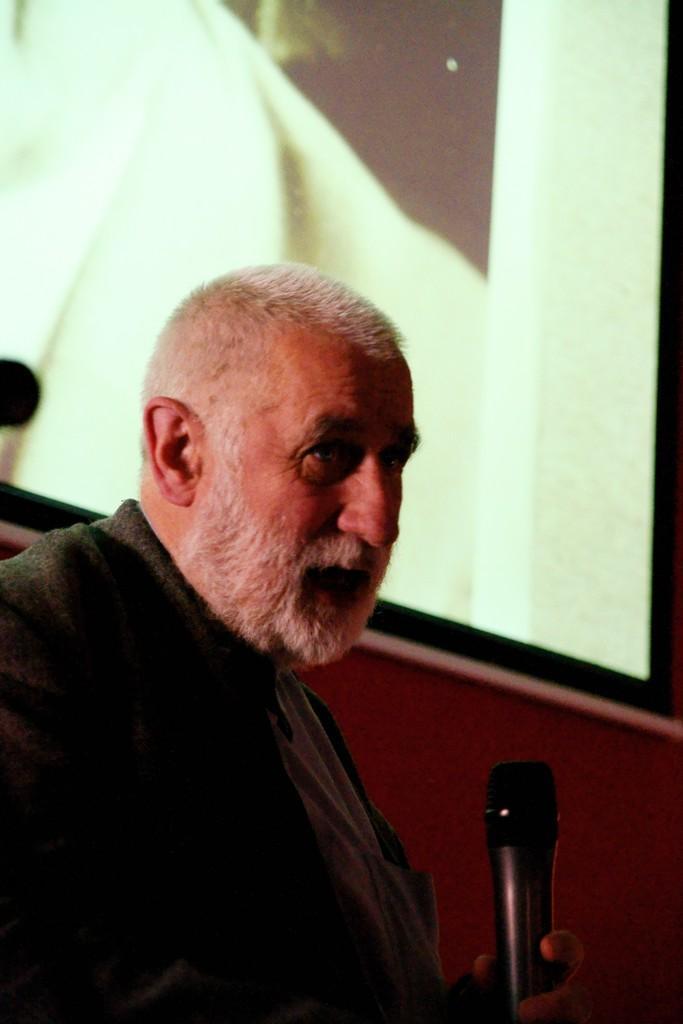Could you give a brief overview of what you see in this image? In this picture i could see a person with a white beard and a jacket on him holding a mic in his left hand. In the background there is a big screen. 